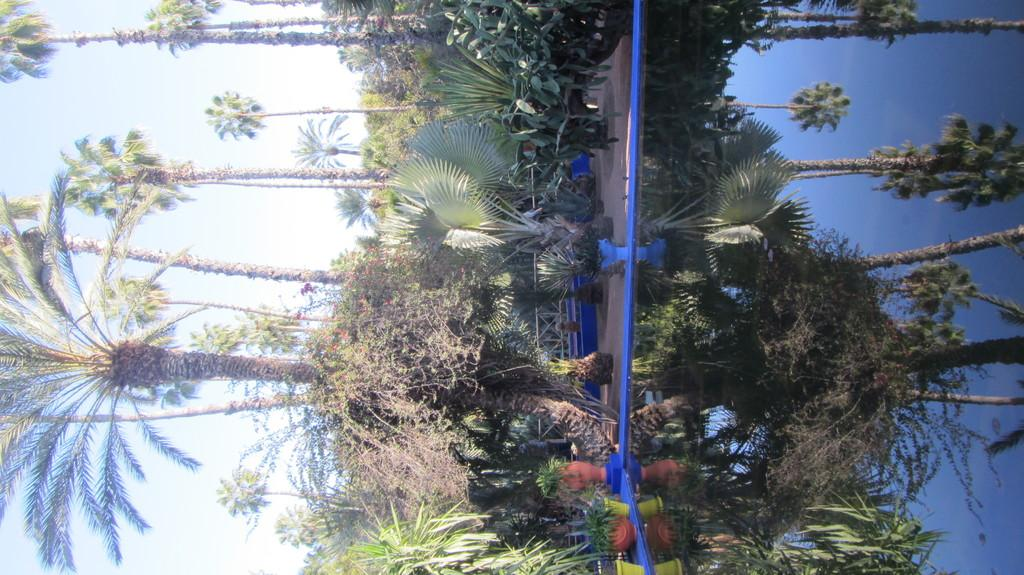What type of natural elements can be seen in the image? There are trees and plants visible in the image. What architectural feature is present in the image? There is a railing in the image. What is visible in the background of the image? Sky and water are visible in the image. Can you describe the reflection in the water? The reflection of trees, plants, and sky can be seen in the water. What else can be found in the image? There are objects in the image. What is the tendency of the frame in the image? There is no frame present in the image, so it is not possible to determine any tendency. 